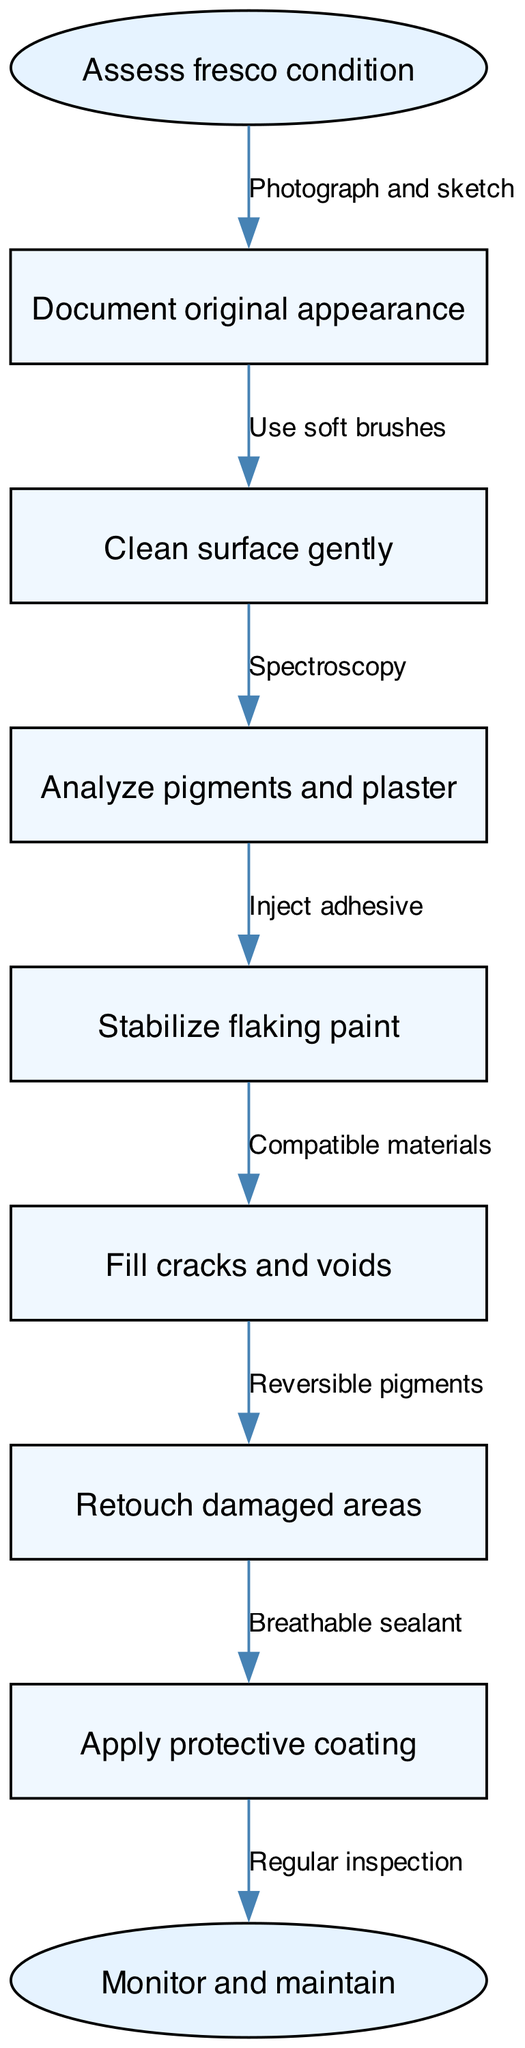What is the first step in restoring a fresco? The diagram indicates that the first step in restoring a fresco is to assess the fresco condition. This is the starting point of the flow chart.
Answer: Assess fresco condition How many intermediate steps are there in the restoration process? By counting the nodes between the start and end nodes, there are six intermediate steps detailed in the diagram.
Answer: 6 What is the last action taken before applying the protective coating? The diagram shows that the last action before applying the protective coating is to retouch damaged areas. This is a crucial step to ensure the fresco's appearance is restored.
Answer: Retouch damaged areas What method is indicated for cleaning the surface of the fresco? The diagram specifies that the surface should be cleaned gently using soft brushes. This helps to avoid damaging the fresco during the cleaning process.
Answer: Use soft brushes What is used to stabilize flaking paint? The diagram indicates that an adhesive should be injected to stabilize flaking paint. This step is essential to preserve the integrity of the paint on the fresco.
Answer: Inject adhesive How does one fill cracks and voids in the fresco? According to the diagram, cracks and voids are filled using compatible materials. This ensures that the repair is effective and does not damage the original artwork.
Answer: Compatible materials What technique is employed to analyze pigments and plaster? The diagram indicates that spectroscopy is used for analyzing pigments and plaster. This scientific technique allows conservators to understand the materials used in the fresco.
Answer: Spectroscopy What is the purpose of applying a protective coating? The protective coating is applied to seal the fresco and ensure its longevity, as indicated in the diagram. It acts as a barrier against environmental damage while allowing the fresco to breathe.
Answer: Breathable sealant Which step follows stabilizing flaking paint? After stabilizing flaking paint, the next step is to fill cracks and voids. This is a sequential process aimed at repairing the areas affected by deterioration.
Answer: Fill cracks and voids 